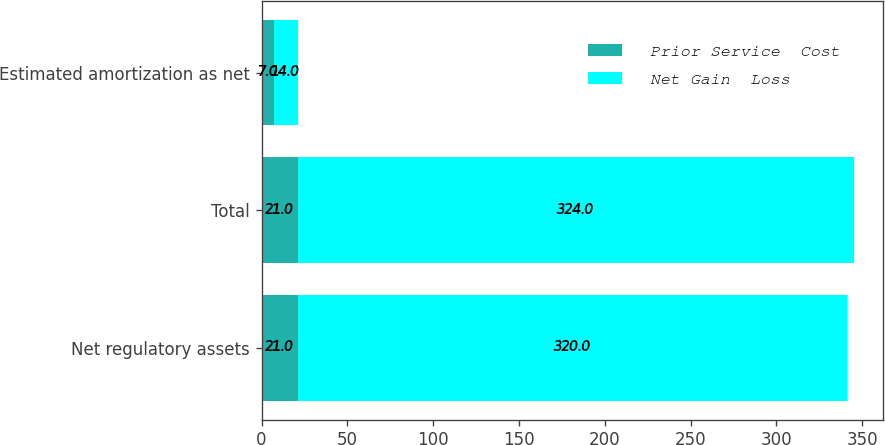Convert chart. <chart><loc_0><loc_0><loc_500><loc_500><stacked_bar_chart><ecel><fcel>Net regulatory assets<fcel>Total<fcel>Estimated amortization as net<nl><fcel>Prior Service  Cost<fcel>21<fcel>21<fcel>7<nl><fcel>Net Gain  Loss<fcel>320<fcel>324<fcel>14<nl></chart> 